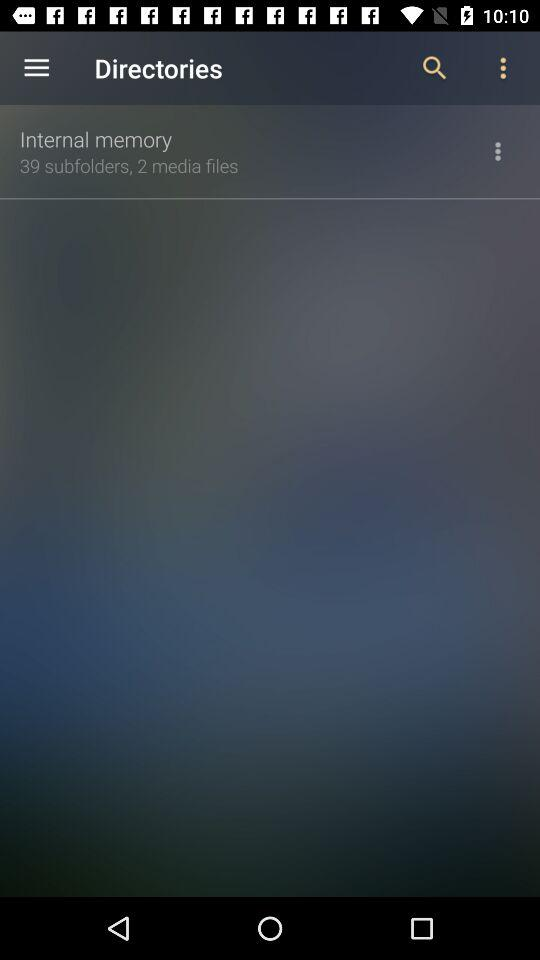How many more subfolders does the Internal memory have than media files?
Answer the question using a single word or phrase. 37 